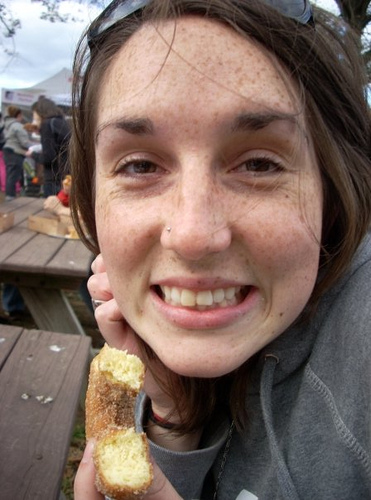What is the setting behind the person? The setting behind the person seems to be an outdoor area, possibly a festival or outdoor market, judging by the white tents and casual outdoor seating, such as picnic tables. It looks like a place where people can enjoy food and drinks in a casual atmosphere. 